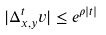Convert formula to latex. <formula><loc_0><loc_0><loc_500><loc_500>| \Delta _ { x , y } ^ { t } v | \leq e ^ { \rho | t | }</formula> 